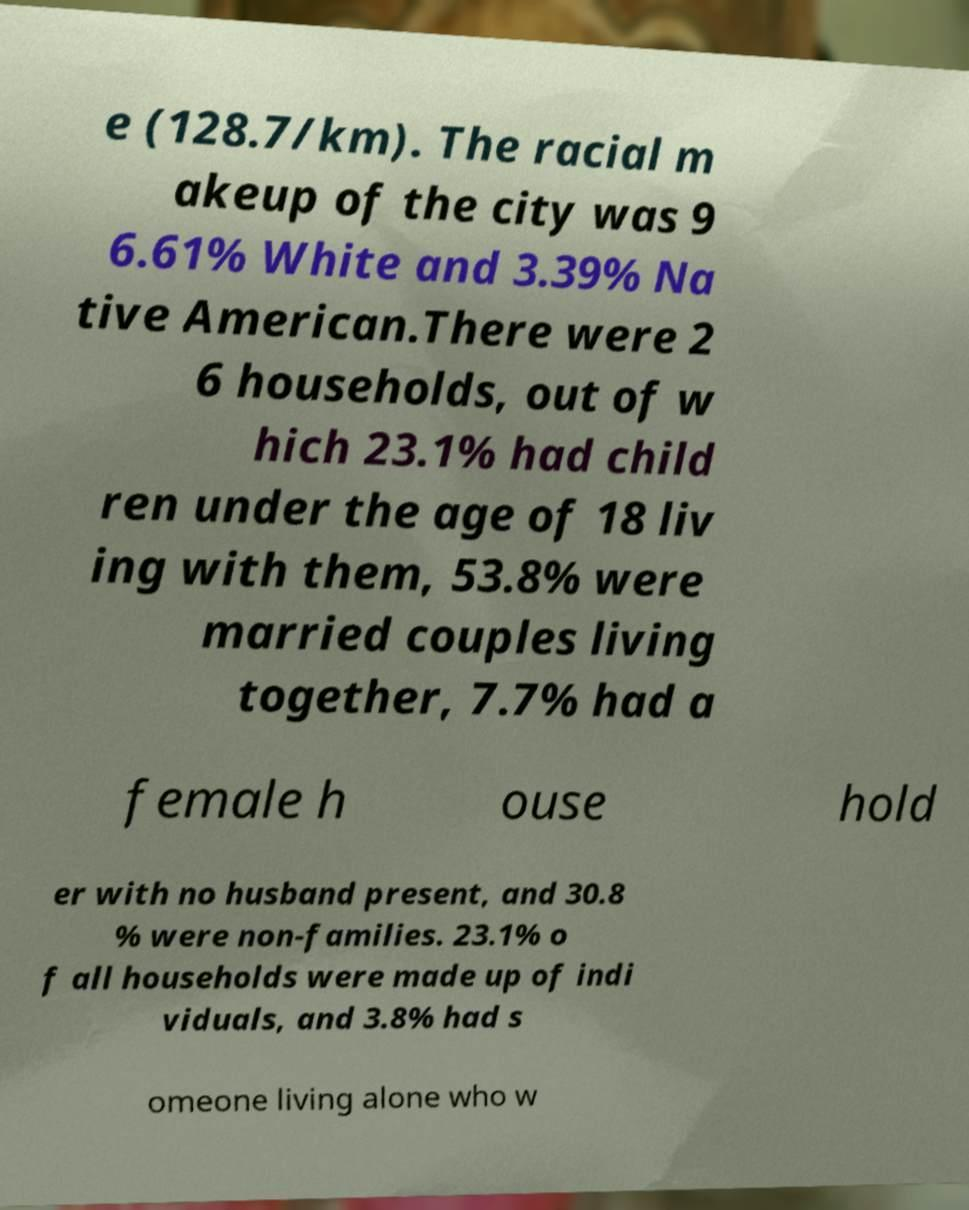Could you assist in decoding the text presented in this image and type it out clearly? e (128.7/km). The racial m akeup of the city was 9 6.61% White and 3.39% Na tive American.There were 2 6 households, out of w hich 23.1% had child ren under the age of 18 liv ing with them, 53.8% were married couples living together, 7.7% had a female h ouse hold er with no husband present, and 30.8 % were non-families. 23.1% o f all households were made up of indi viduals, and 3.8% had s omeone living alone who w 